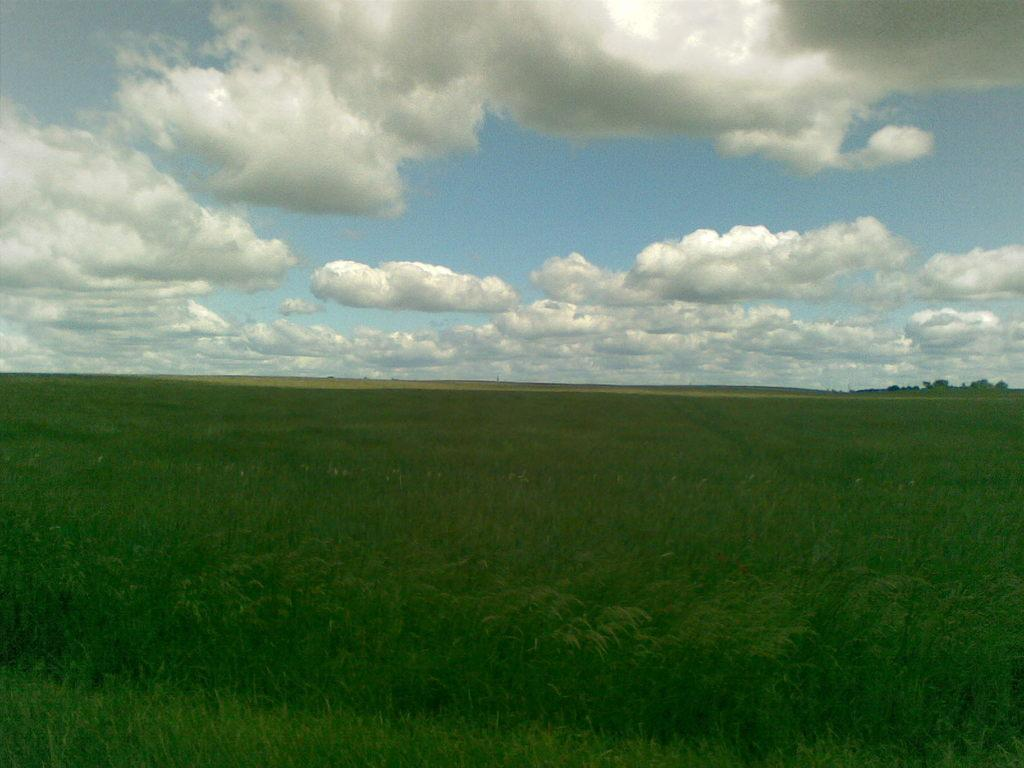What is the main feature of the image's center? The center of the image contains the sky. What can be seen in the sky? Clouds are present in the sky. What type of vegetation is visible in the image? Trees are visible in the image. What is the ground covered with in the image? Grass is present in the image. What type of quartz can be seen in the image? There is no quartz present in the image. Can you tell me how the mountain in the image affects the landscape? There is no mountain present in the image. 